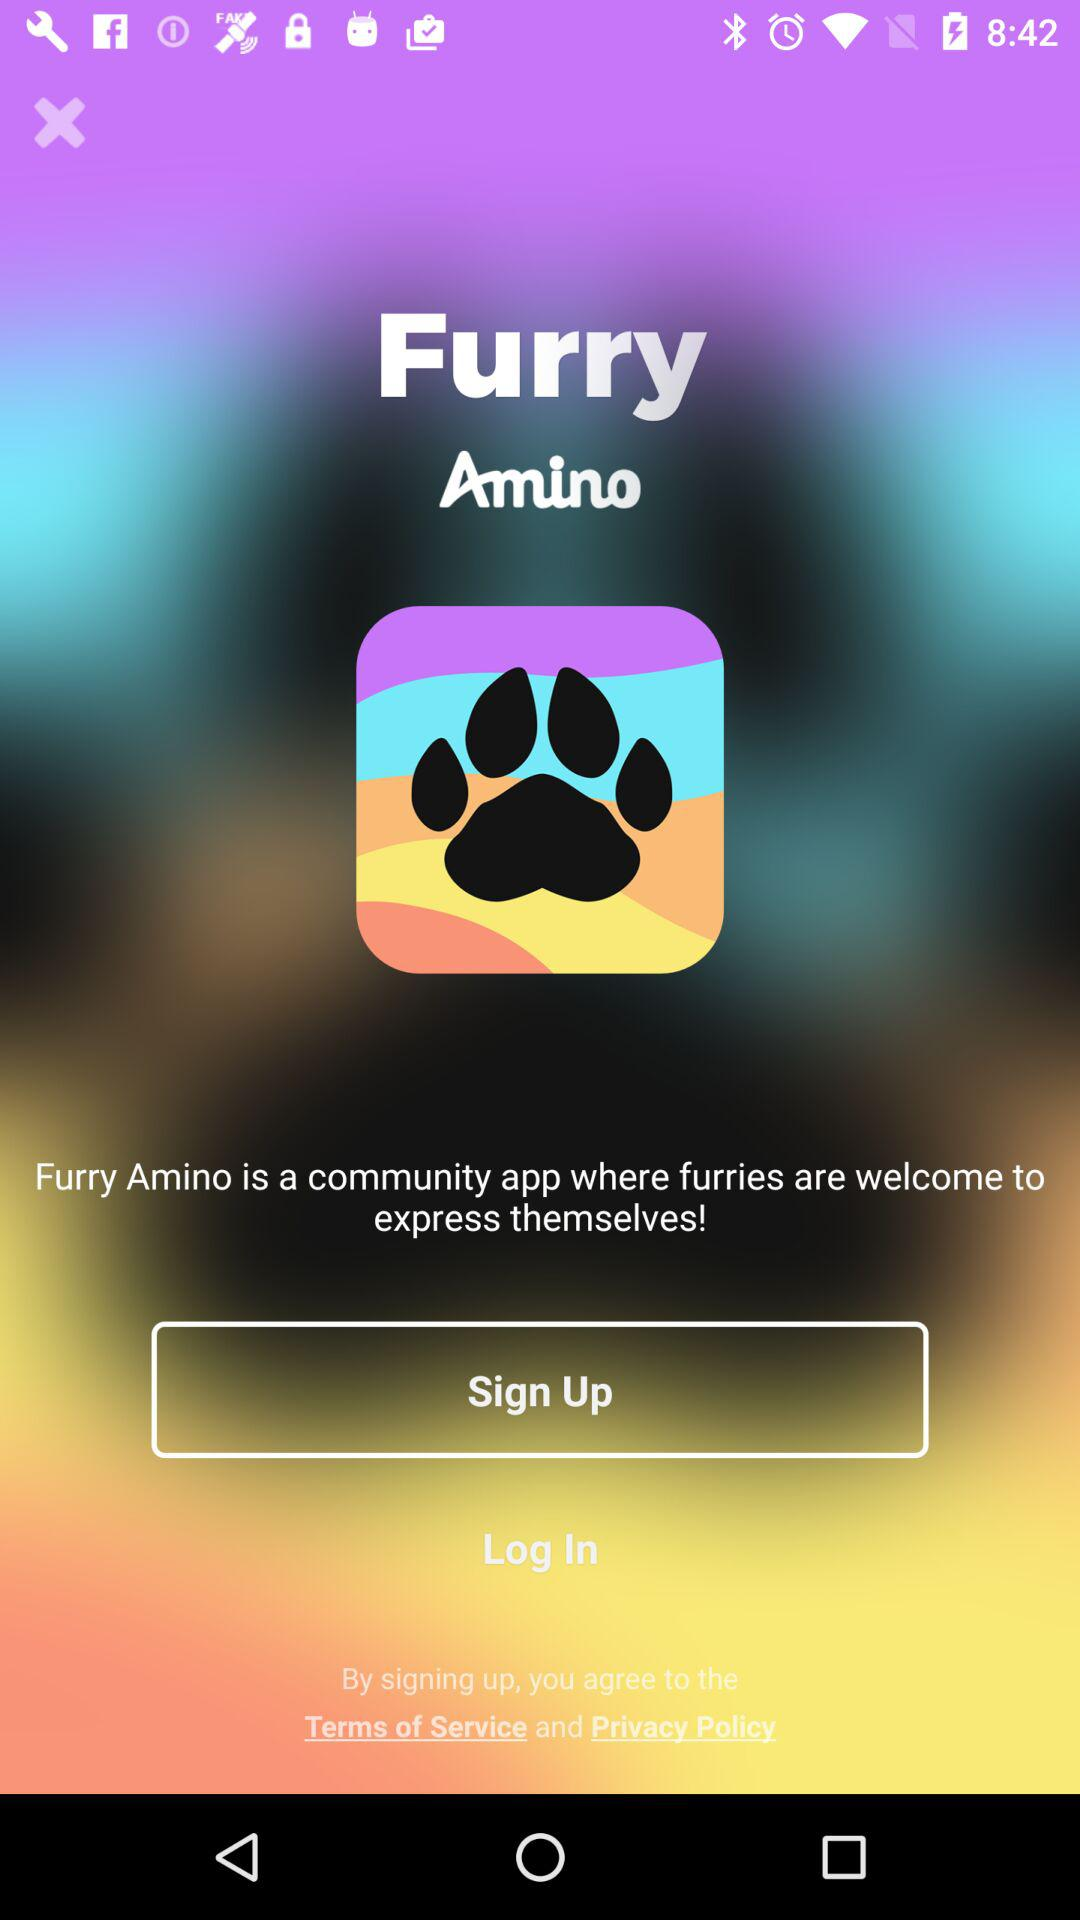What is the app name? The app name is "Furry Amino". 